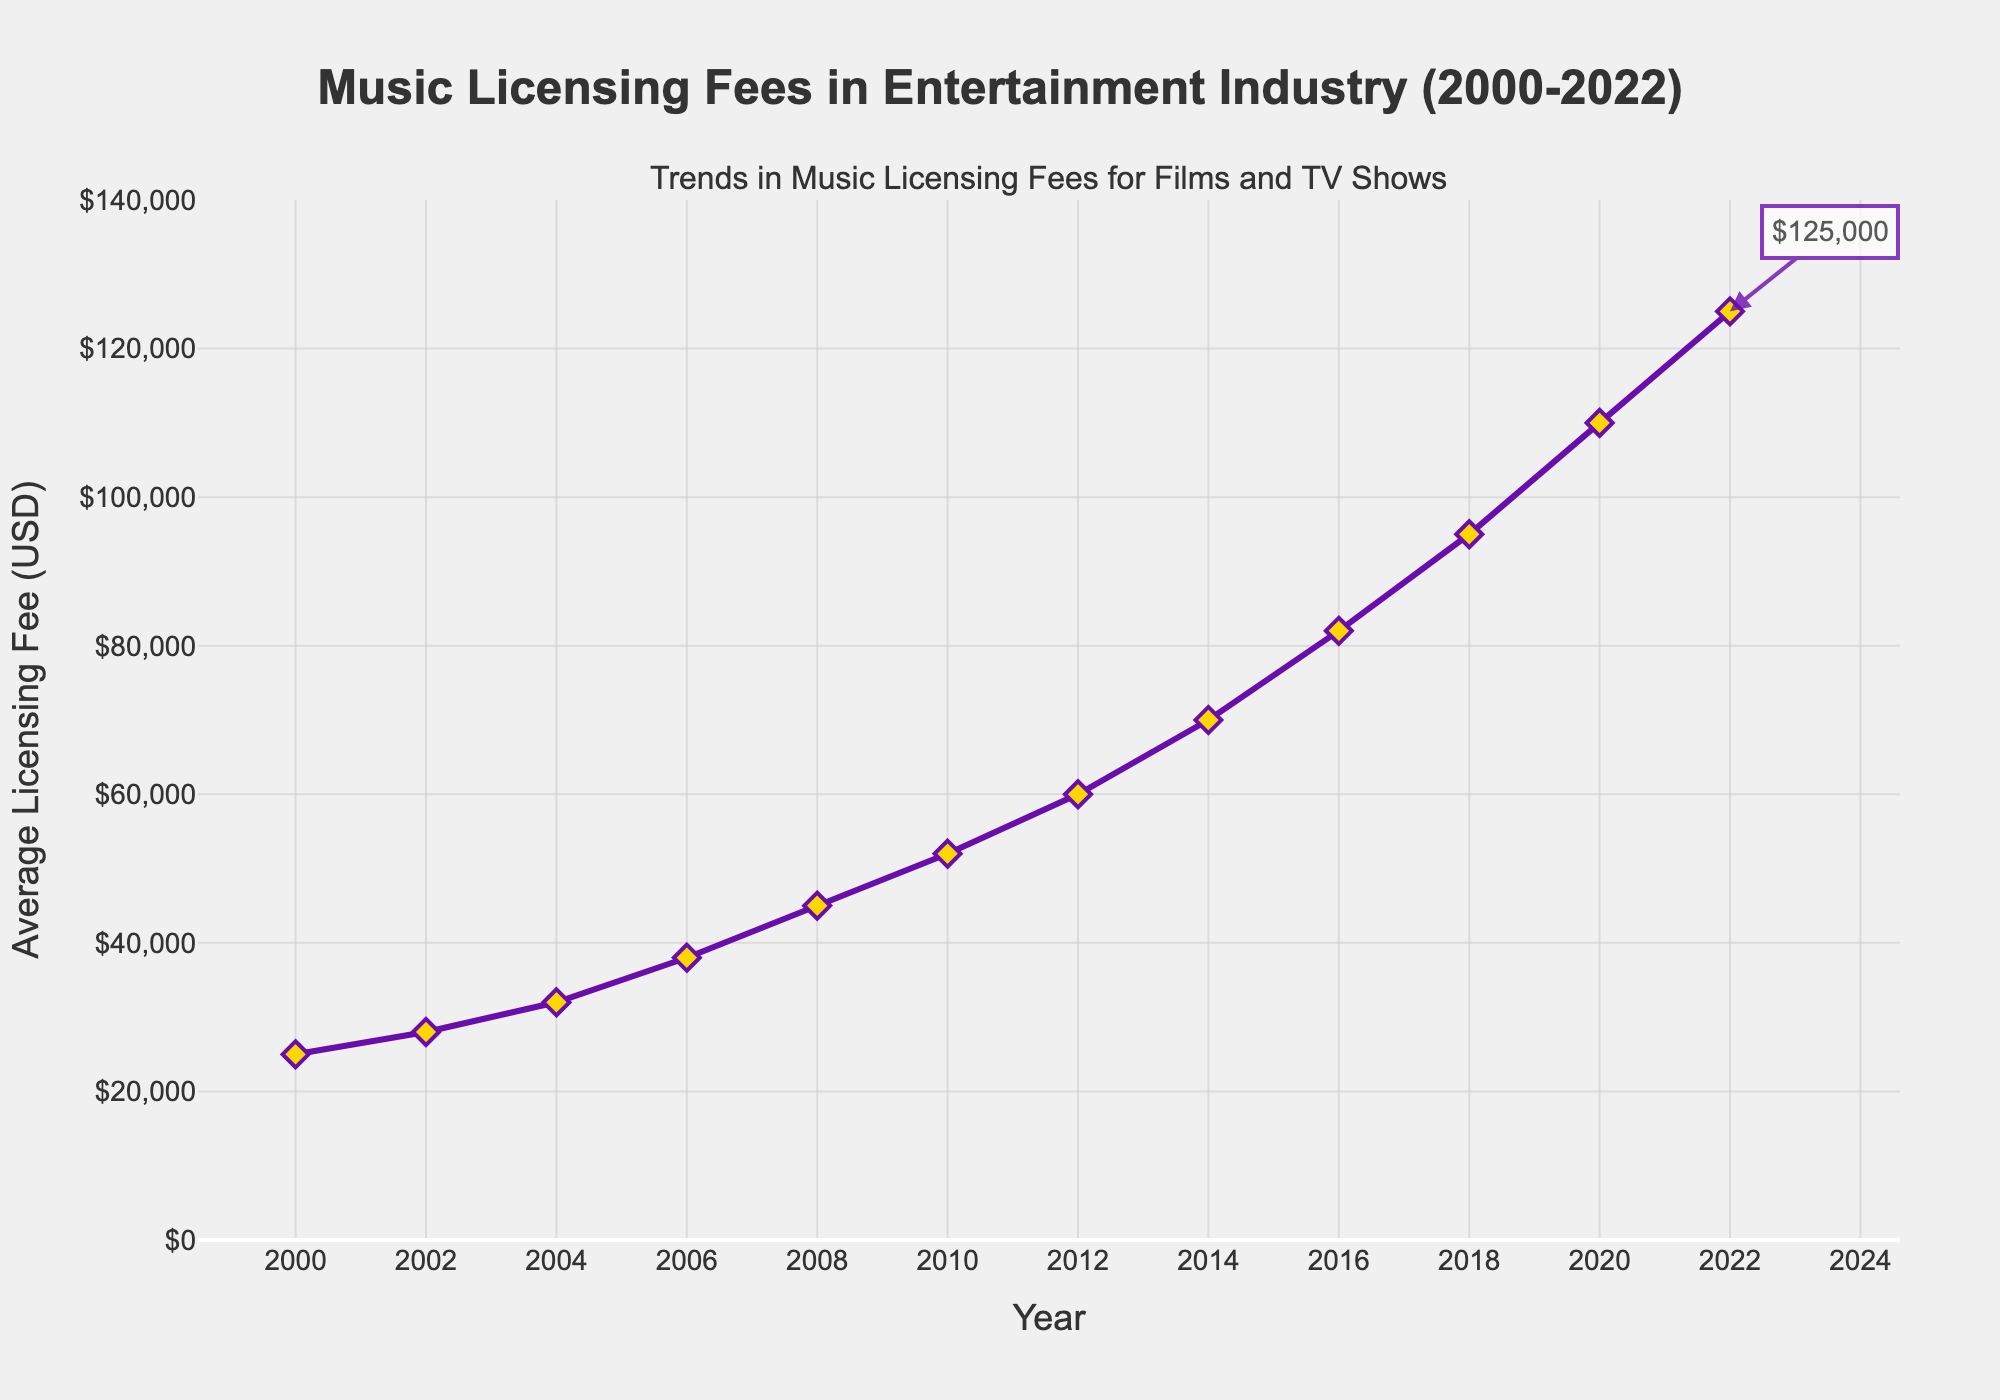What was the average licensing fee in 2008? Locate the year 2008 on the x-axis and read the corresponding value on the y-axis. The average licensing fee in 2008 is represented by the point on the line chart.
Answer: $45,000 By how much did the average licensing fee increase from 2000 to 2010? Note the values for the years 2000 ($25,000) and 2010 ($52,000). Subtract the 2000 value from the 2010 value to find the increase: $52,000 - $25,000 = $27,000
Answer: $27,000 What was the percentage increase in the average licensing fee between 2018 and 2022? Find the values for 2018 ($95,000) and 2022 ($125,000). Calculate the percentage increase: ((125,000 - 95,000) / 95,000) * 100 ≈ 31.58%
Answer: 31.58% In which year did the average licensing fee surpass $100,000 for the first time? Look at the y-axis and find the year where the line representing the average licensing fee crosses the $100,000 mark. This first occurs in 2020.
Answer: 2020 What is the overall trend in average licensing fees from 2000 to 2022? Observe the line from 2000 to 2022, which consistently ascends. This indicates an overall increasing trend in average licensing fees over the years.
Answer: Increasing trend How does the average licensing fee in 2016 compare to that in 2002? Locate the years 2016 and 2002 on the x-axis and compare their corresponding values on the y-axis. In 2016, it is $82,000, and in 2002, it is $28,000. Therefore, 2016's licensing fee is significantly higher.
Answer: 2016 is higher By what factor did the average licensing fee increase from 2000 to 2022? Divide the 2022 value ($125,000) by the 2000 value ($25,000) to get the factor of increase: $125,000 / $25,000 = 5.
Answer: 5 Which year shows the highest single-year increase in the average licensing fee? Calculate the yearly differences and identify the highest increase. The biggest increase is between 2008 ($45,000) and 2010 ($52,000), which is $7,000.
Answer: 2010 What is the visual significance of the point at 2022 on the chart? The point at 2022 is highlighted with an annotation that reads "$125,000", indicating it has a significant value and is the highest on the chart.
Answer: Highest value, annotated Do the licensing fees show any instances of decline from one year to the next? Observe the line chart from 2000 to 2022 and note if the line ever goes downward. It does not; the trend is consistently upward.
Answer: No decline 